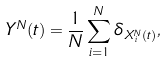Convert formula to latex. <formula><loc_0><loc_0><loc_500><loc_500>Y ^ { N } ( t ) = \frac { 1 } { N } \sum _ { i = 1 } ^ { N } \delta _ { X ^ { N } _ { i } ( t ) } ,</formula> 